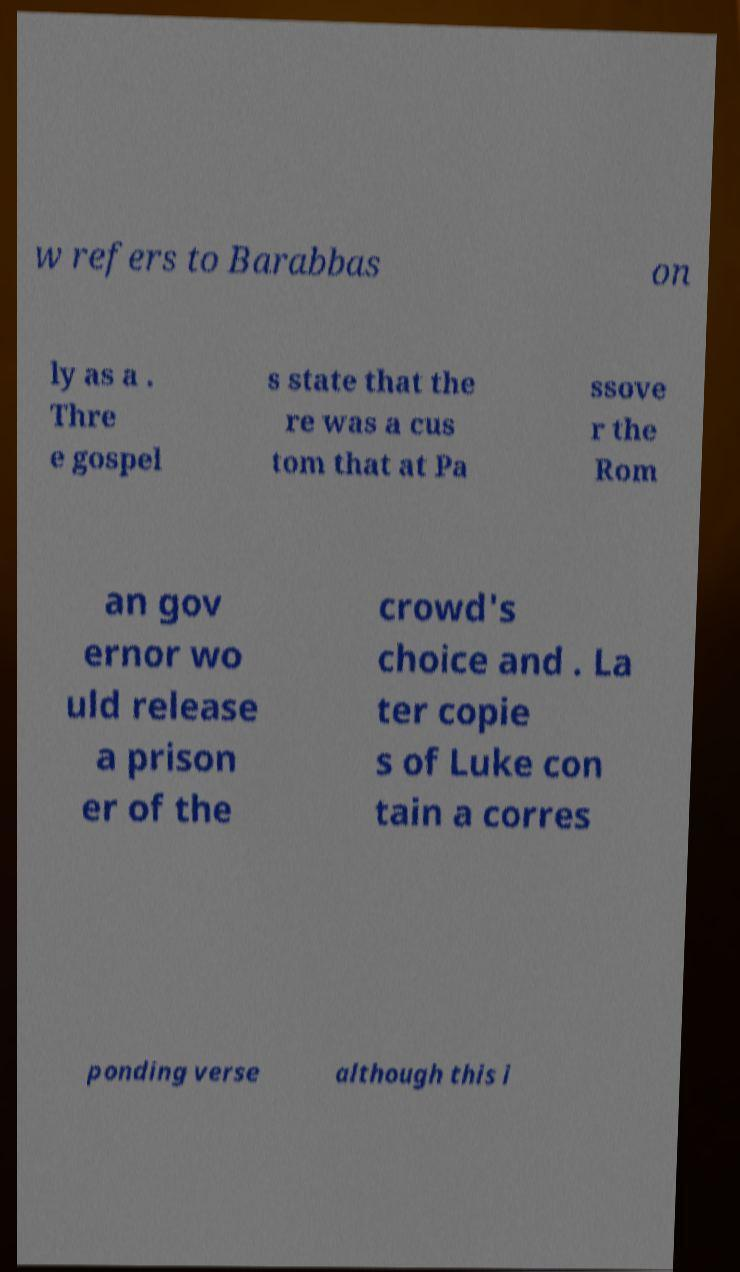Can you accurately transcribe the text from the provided image for me? w refers to Barabbas on ly as a . Thre e gospel s state that the re was a cus tom that at Pa ssove r the Rom an gov ernor wo uld release a prison er of the crowd's choice and . La ter copie s of Luke con tain a corres ponding verse although this i 